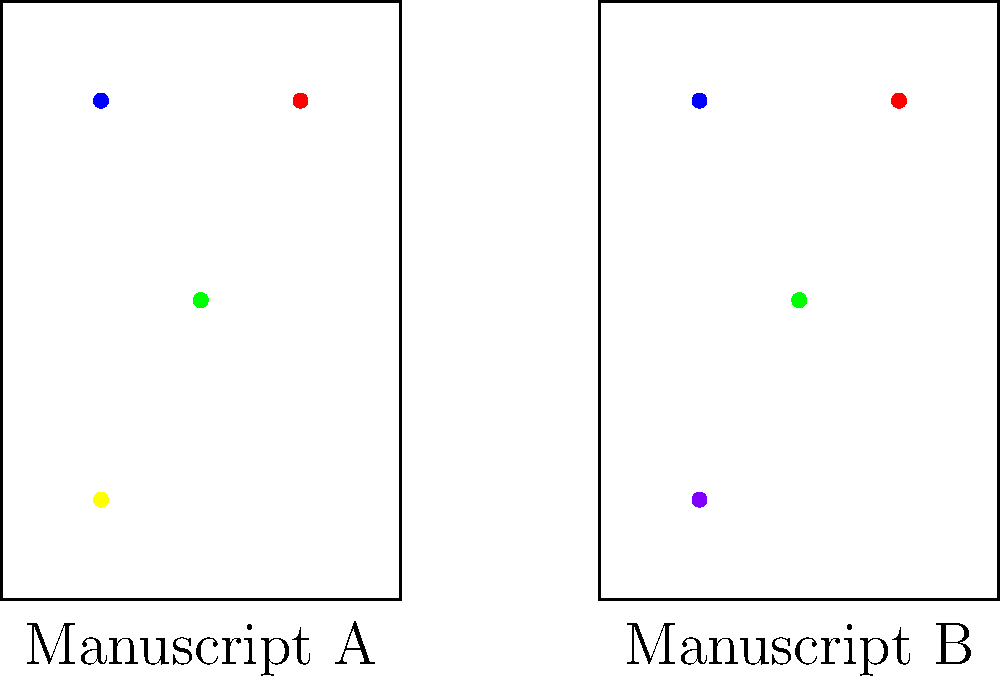Examine the two illuminated manuscripts depicted above, labeled A and B. How many differences can you identify between them? To identify the differences between the two manuscripts, we need to compare them systematically:

1. Overall structure: Both manuscripts have the same rectangular shape and size. No difference here.

2. Blue dot: Both manuscripts have a blue dot in the upper-left corner. No difference.

3. Red dot: Both manuscripts have a red dot in the upper-right corner. No difference.

4. Green dot: Both manuscripts have a green dot in the center. No difference.

5. Bottom dot:
   - Manuscript A has a yellow dot in the bottom-left corner.
   - Manuscript B has a purple dot in the bottom-left corner.
   This is the only difference between the two manuscripts.

Therefore, there is only one difference between Manuscript A and Manuscript B.
Answer: 1 